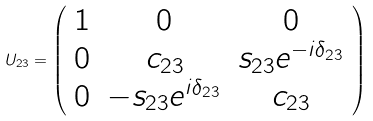<formula> <loc_0><loc_0><loc_500><loc_500>U _ { 2 3 } = \left ( \begin{array} { c c c } { 1 } & { 0 } & { 0 } \\ { 0 } & { { c _ { 2 3 } } } & { { s _ { 2 3 } e ^ { - i \delta _ { 2 3 } } } } \\ { 0 } & { { - s _ { 2 3 } e ^ { i \delta _ { 2 3 } } } } & { { c _ { 2 3 } } } \end{array} \right )</formula> 